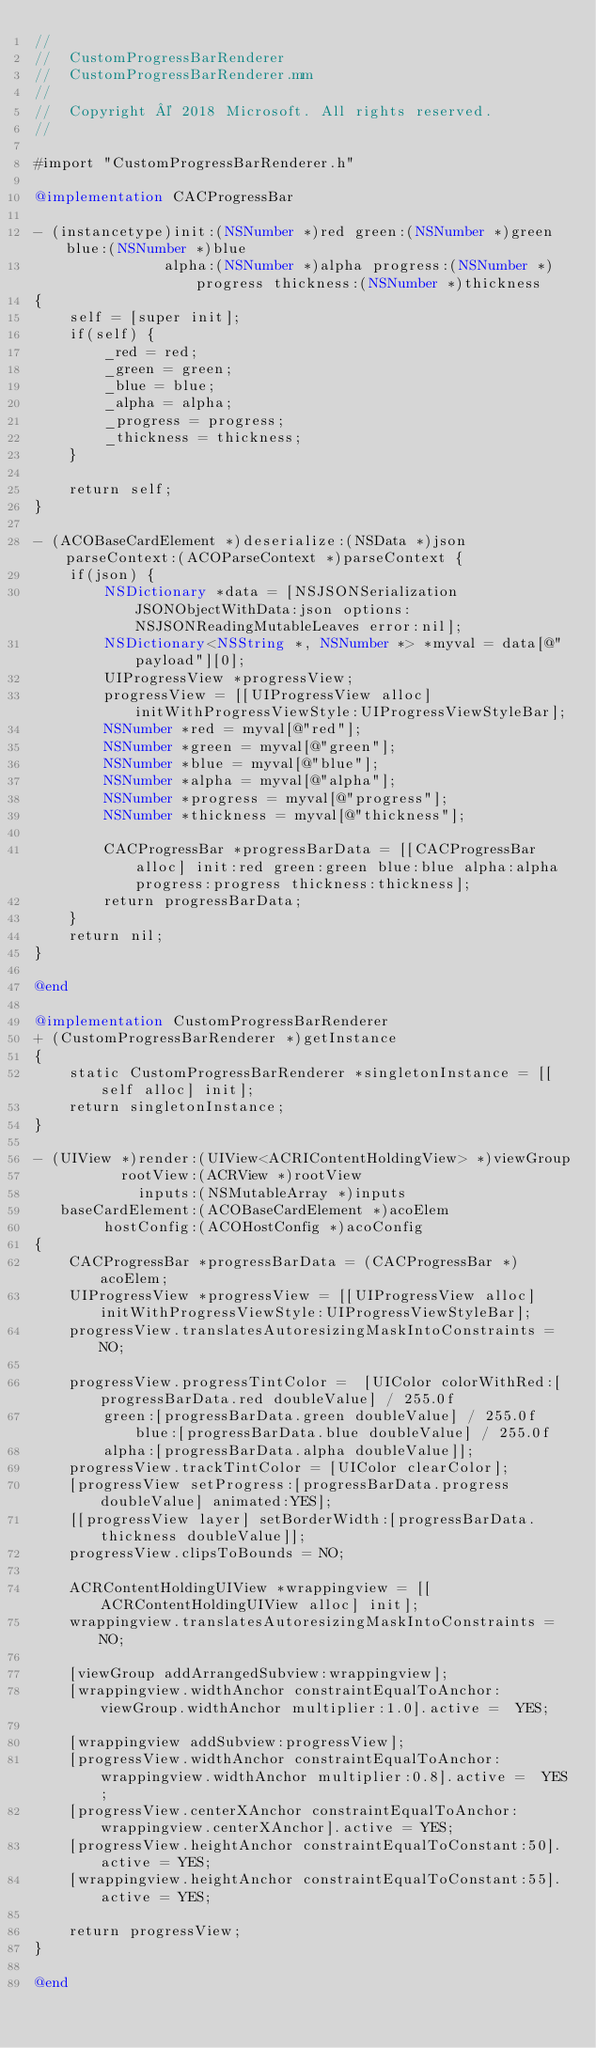Convert code to text. <code><loc_0><loc_0><loc_500><loc_500><_ObjectiveC_>//
//  CustomProgressBarRenderer
//  CustomProgressBarRenderer.mm
//
//  Copyright © 2018 Microsoft. All rights reserved.
//

#import "CustomProgressBarRenderer.h"

@implementation CACProgressBar

- (instancetype)init:(NSNumber *)red green:(NSNumber *)green blue:(NSNumber *)blue
               alpha:(NSNumber *)alpha progress:(NSNumber *)progress thickness:(NSNumber *)thickness
{
    self = [super init];
    if(self) {
        _red = red;
        _green = green;
        _blue = blue;
        _alpha = alpha;
        _progress = progress;
        _thickness = thickness;
    }

    return self;
}

- (ACOBaseCardElement *)deserialize:(NSData *)json parseContext:(ACOParseContext *)parseContext {
    if(json) {
        NSDictionary *data = [NSJSONSerialization JSONObjectWithData:json options:NSJSONReadingMutableLeaves error:nil];
        NSDictionary<NSString *, NSNumber *> *myval = data[@"payload"][0];
        UIProgressView *progressView;
        progressView = [[UIProgressView alloc] initWithProgressViewStyle:UIProgressViewStyleBar];
        NSNumber *red = myval[@"red"];
        NSNumber *green = myval[@"green"];
        NSNumber *blue = myval[@"blue"];
        NSNumber *alpha = myval[@"alpha"];
        NSNumber *progress = myval[@"progress"];
        NSNumber *thickness = myval[@"thickness"];

        CACProgressBar *progressBarData = [[CACProgressBar alloc] init:red green:green blue:blue alpha:alpha progress:progress thickness:thickness];
        return progressBarData;
    }
    return nil;
}

@end

@implementation CustomProgressBarRenderer
+ (CustomProgressBarRenderer *)getInstance
{
    static CustomProgressBarRenderer *singletonInstance = [[self alloc] init];
    return singletonInstance;
}

- (UIView *)render:(UIView<ACRIContentHoldingView> *)viewGroup
          rootView:(ACRView *)rootView
            inputs:(NSMutableArray *)inputs
   baseCardElement:(ACOBaseCardElement *)acoElem
        hostConfig:(ACOHostConfig *)acoConfig
{
    CACProgressBar *progressBarData = (CACProgressBar *)acoElem;
    UIProgressView *progressView = [[UIProgressView alloc] initWithProgressViewStyle:UIProgressViewStyleBar];
    progressView.translatesAutoresizingMaskIntoConstraints = NO;

    progressView.progressTintColor =  [UIColor colorWithRed:[progressBarData.red doubleValue] / 255.0f
        green:[progressBarData.green doubleValue] / 255.0f blue:[progressBarData.blue doubleValue] / 255.0f
        alpha:[progressBarData.alpha doubleValue]];
    progressView.trackTintColor = [UIColor clearColor];
    [progressView setProgress:[progressBarData.progress doubleValue] animated:YES];
    [[progressView layer] setBorderWidth:[progressBarData.thickness doubleValue]];
    progressView.clipsToBounds = NO;

    ACRContentHoldingUIView *wrappingview = [[ACRContentHoldingUIView alloc] init];
    wrappingview.translatesAutoresizingMaskIntoConstraints = NO;
    
    [viewGroup addArrangedSubview:wrappingview];
    [wrappingview.widthAnchor constraintEqualToAnchor:viewGroup.widthAnchor multiplier:1.0].active =  YES;

    [wrappingview addSubview:progressView];
    [progressView.widthAnchor constraintEqualToAnchor:wrappingview.widthAnchor multiplier:0.8].active =  YES;
    [progressView.centerXAnchor constraintEqualToAnchor:wrappingview.centerXAnchor].active = YES;
    [progressView.heightAnchor constraintEqualToConstant:50].active = YES;
    [wrappingview.heightAnchor constraintEqualToConstant:55].active = YES;

    return progressView;
}

@end


</code> 